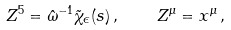Convert formula to latex. <formula><loc_0><loc_0><loc_500><loc_500>Z ^ { 5 } = { \hat { \omega } } ^ { - 1 } \tilde { \chi } _ { \epsilon } ( s ) \, , \quad Z ^ { \mu } = x ^ { \mu } \, ,</formula> 